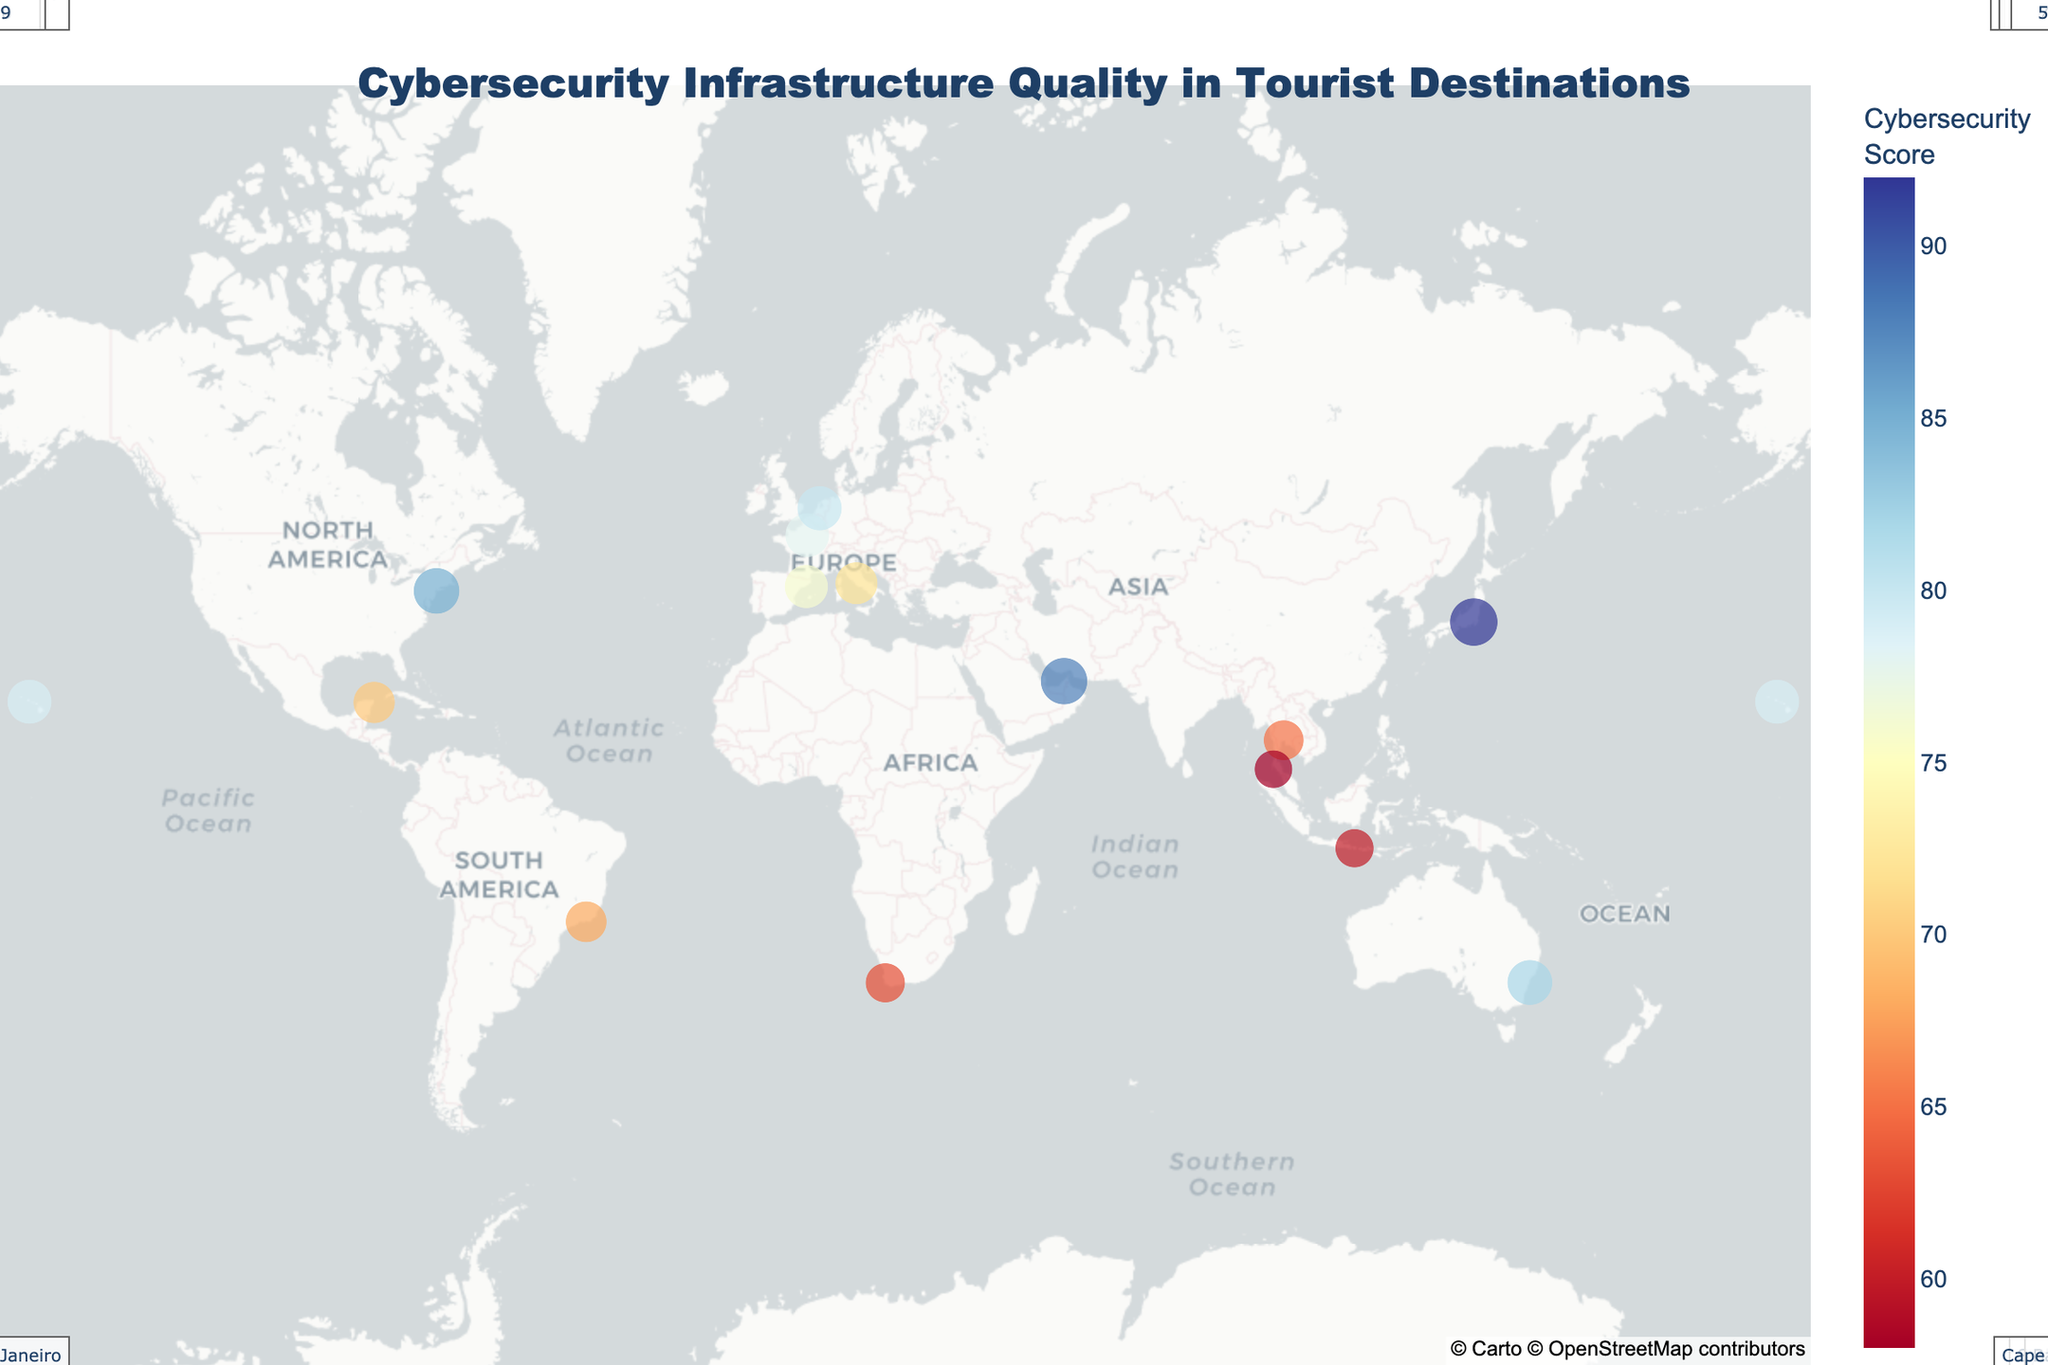What is the title of the figure? The title is usually located at the top of the figure and is designed to provide an overview of the plot. In this case, the title according to the code is "Cybersecurity Infrastructure Quality in Tourist Destinations".
Answer: Cybersecurity Infrastructure Quality in Tourist Destinations Which region has the highest cybersecurity score? By examining the annotations and color intensity of the dots on the map, Tokyo stands out due to its relatively higher cybersecurity score of 92.
Answer: Tokyo What is the cybersecurity score for Bangkok? The figure includes annotations for each region's cybersecurity score. By locating Bangkok on the map, we can see that its score is 65.
Answer: 65 Compare the cybersecurity scores of Dubai and Rome. Which one is higher? Identifying the positions of Dubai and Rome on the map and reading their cybersecurity scores from the annotations show that Dubai has a score of 88, while Rome has a score of 72. Therefore, Dubai’s score is higher.
Answer: Dubai What is the average cybersecurity score for all regions? To find the average, sum up all the cybersecurity scores provided (85+78+92+72+65+88+82+68+80+60+70+63+79+76+58) which equals 1116. Then, divide this sum by the number of regions (15). The average score is 1116 / 15 = 74.4.
Answer: 74.4 Which regions have a cybersecurity score below 70? From the annotations and colors, the regions with scores below 70 are Bangkok (65), Rio de Janeiro (68), Bali (60), Cancun (70), Cape Town (63), and Phuket (58).
Answer: Bangkok, Rio de Janeiro, Bali, Cancun, Cape Town, and Phuket What is the cybersecurity score difference between New York City and Bali? Determine the cybersecurity scores for both regions from the map annotations: New York City (85) and Bali (60). The difference is calculated as 85 - 60 = 25.
Answer: 25 What’s the median cybersecurity score of all the regions? To find the median, list the scores in an ascending order (58, 60, 63, 65, 68, 70, 72, 76, 78, 79, 80, 82, 85, 88, 92). With 15 scores, the median is the 8th score, which is 76.
Answer: 76 Which region(s) could be considered as having the highest cybersecurity risk based on the score? The highest cybersecurity risk corresponds to the lowest scores. From the list, Phuket has the lowest score of 58, making it the highest risk region among those shown.
Answer: Phuket How does Sydney’s cybersecurity score compare to that of Honolulu? Sydney's cybersecurity score (82) and Honolulu’s score (79) can be compared side by side. Sydney has a slightly higher score than Honolulu.
Answer: Sydney 